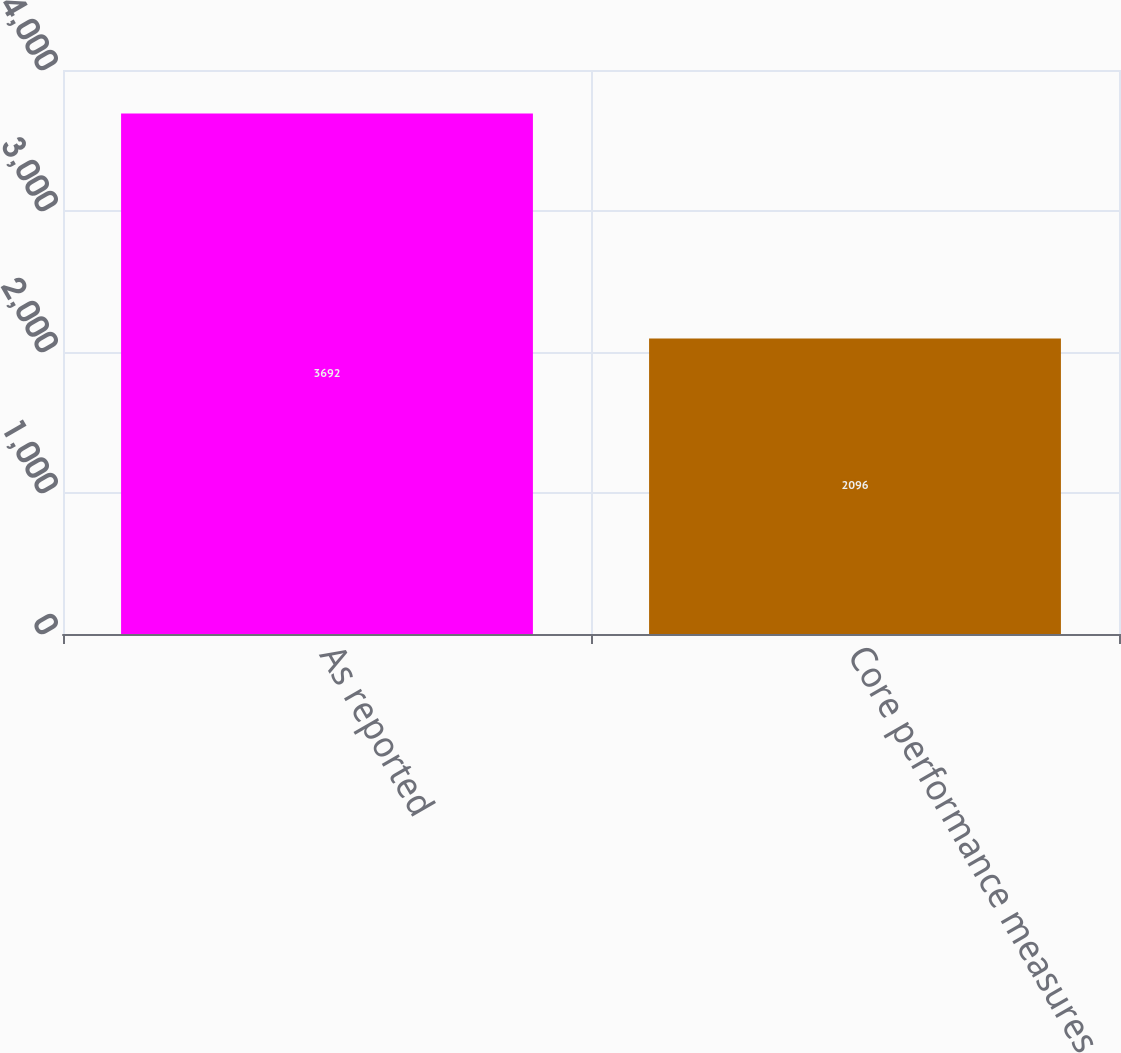Convert chart. <chart><loc_0><loc_0><loc_500><loc_500><bar_chart><fcel>As reported<fcel>Core performance measures<nl><fcel>3692<fcel>2096<nl></chart> 